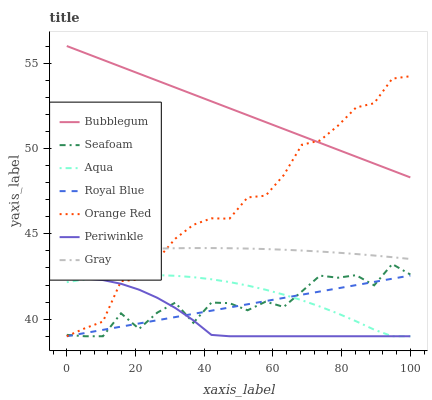Does Periwinkle have the minimum area under the curve?
Answer yes or no. Yes. Does Bubblegum have the maximum area under the curve?
Answer yes or no. Yes. Does Aqua have the minimum area under the curve?
Answer yes or no. No. Does Aqua have the maximum area under the curve?
Answer yes or no. No. Is Royal Blue the smoothest?
Answer yes or no. Yes. Is Seafoam the roughest?
Answer yes or no. Yes. Is Aqua the smoothest?
Answer yes or no. No. Is Aqua the roughest?
Answer yes or no. No. Does Aqua have the lowest value?
Answer yes or no. Yes. Does Bubblegum have the lowest value?
Answer yes or no. No. Does Bubblegum have the highest value?
Answer yes or no. Yes. Does Aqua have the highest value?
Answer yes or no. No. Is Royal Blue less than Bubblegum?
Answer yes or no. Yes. Is Gray greater than Seafoam?
Answer yes or no. Yes. Does Seafoam intersect Royal Blue?
Answer yes or no. Yes. Is Seafoam less than Royal Blue?
Answer yes or no. No. Is Seafoam greater than Royal Blue?
Answer yes or no. No. Does Royal Blue intersect Bubblegum?
Answer yes or no. No. 